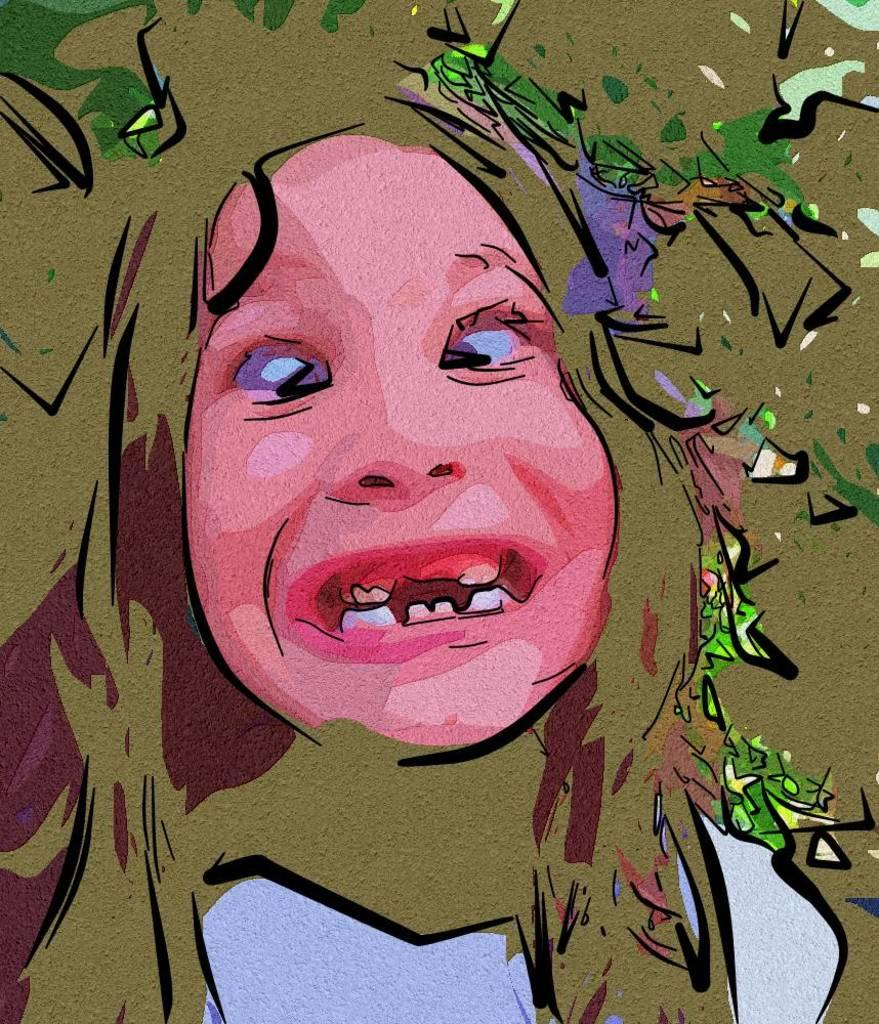What type of image is being described? The image is graphical in nature. What can be seen in the center of the image? There is a person's face in the middle of the image. What type of lettuce is being used to decorate the person's face in the image? There is no lettuce present in the image; it is a graphical representation of a person's face. Is there a dog visible in the image? No, there is no dog present in the image; it only features a person's face. 